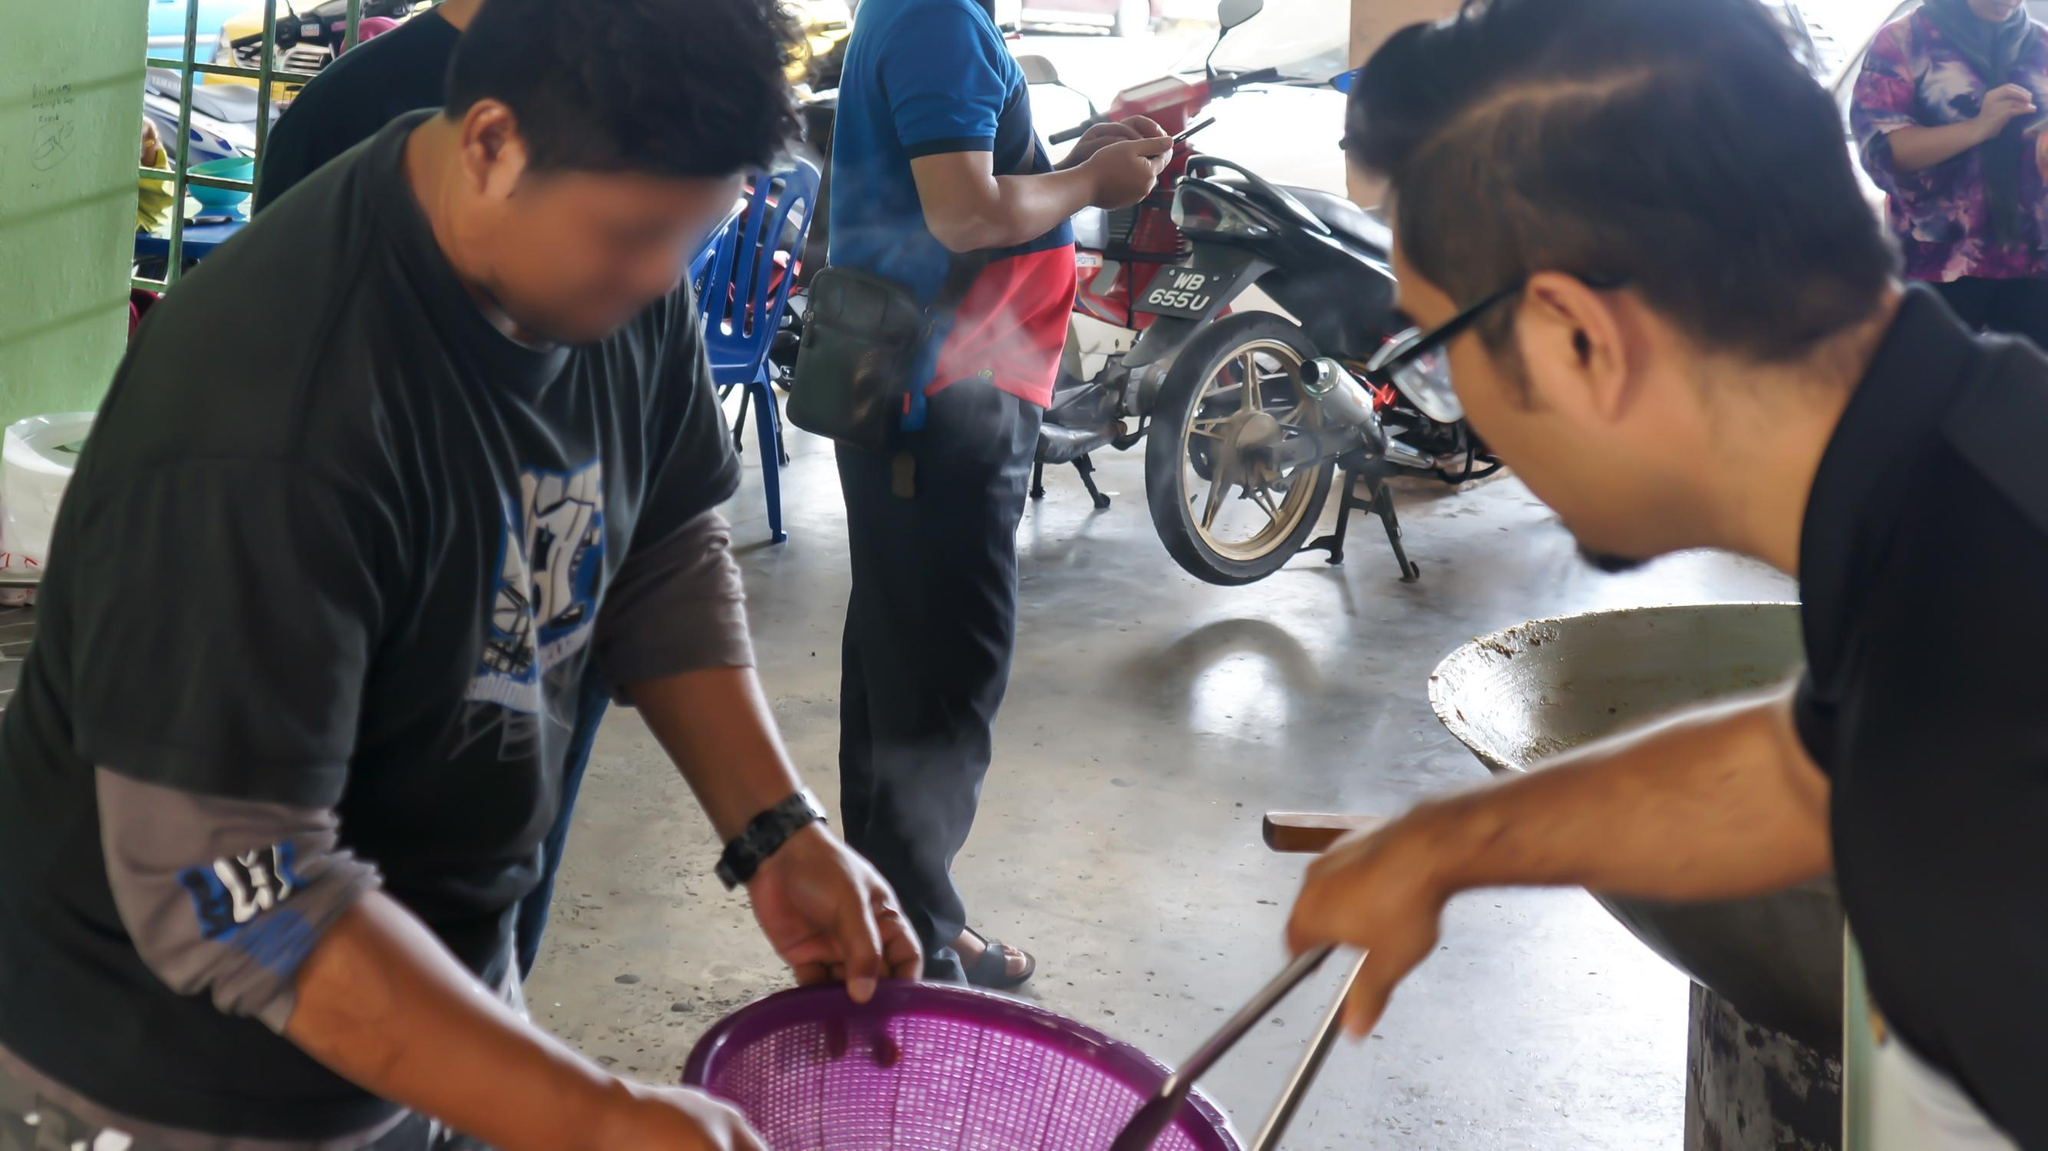What might the discussion between the two men be about? Although we cannot overhear the conversation, their body language suggests a friendly but serious exchange. The man with the glasses, who is pointing, could be inquiring about the price or quality of the item, or perhaps he's requesting a specific quantity. The one holding the basket appears to be explaining or offering information. Such interactions are common in markets where negotiations and discussions about goods are part of the shopping experience. 